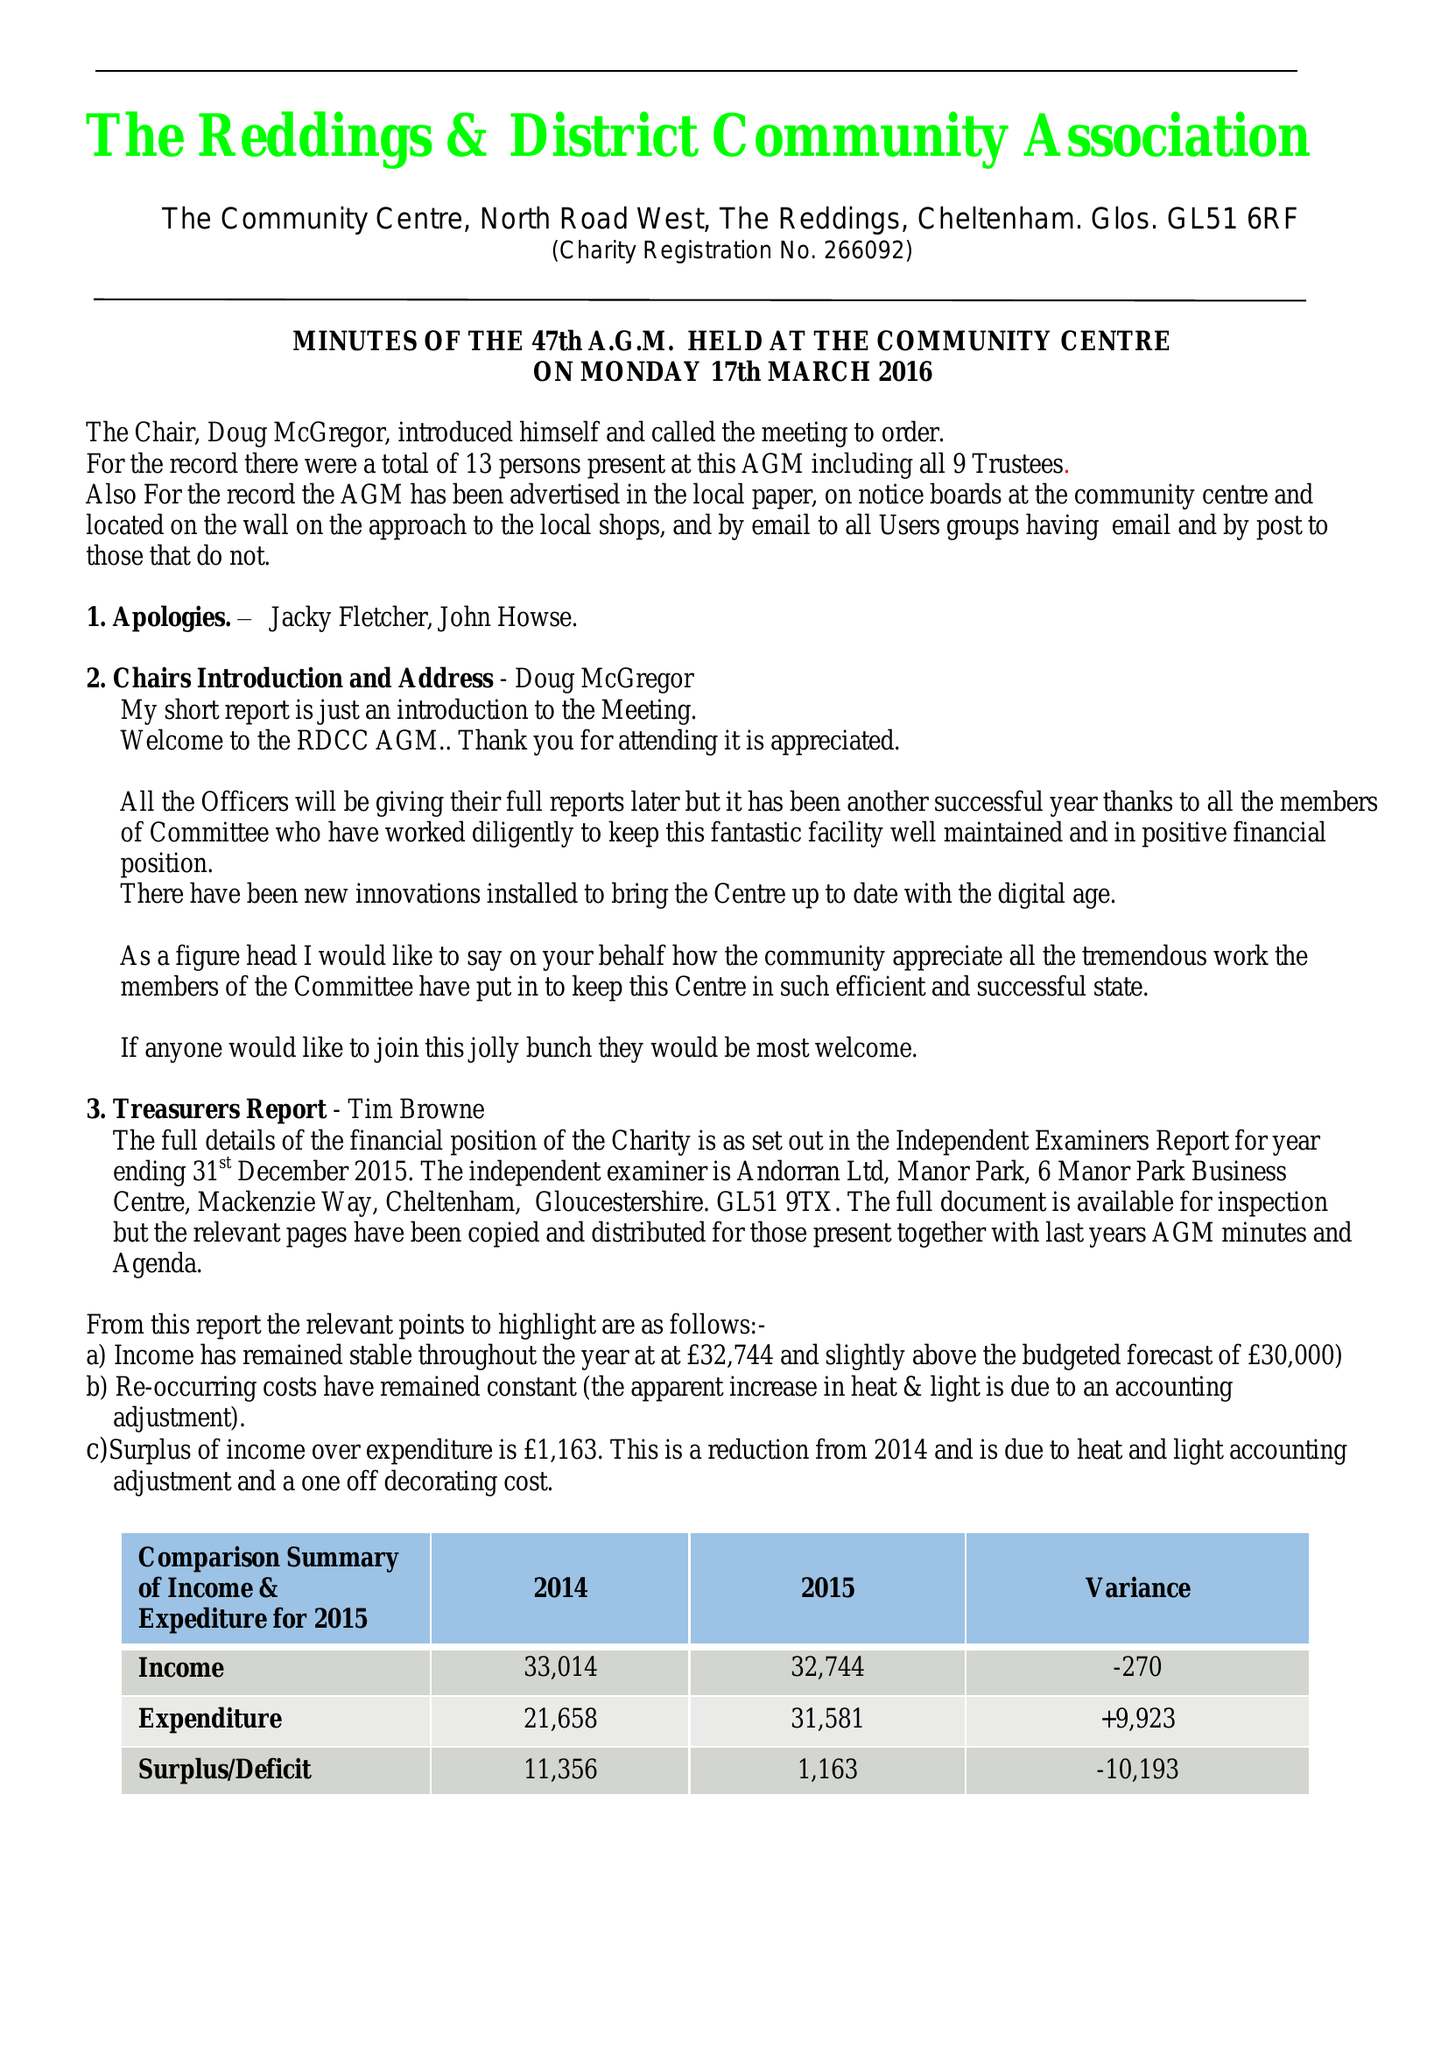What is the value for the address__post_town?
Answer the question using a single word or phrase. CHELTENHAM 